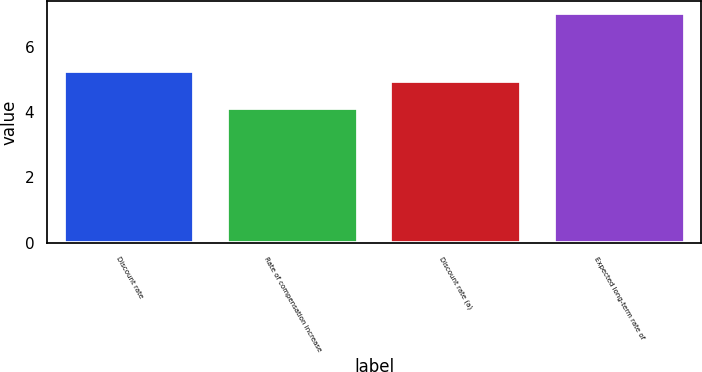Convert chart. <chart><loc_0><loc_0><loc_500><loc_500><bar_chart><fcel>Discount rate<fcel>Rate of compensation increase<fcel>Discount rate (a)<fcel>Expected long-term rate of<nl><fcel>5.25<fcel>4.13<fcel>4.96<fcel>7.04<nl></chart> 